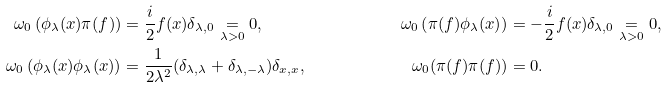Convert formula to latex. <formula><loc_0><loc_0><loc_500><loc_500>\omega _ { 0 } \left ( \phi _ { \lambda } ( x ) \pi ( f ) \right ) & = \frac { i } { 2 } f ( x ) \delta _ { \lambda , 0 } \underset { \lambda > 0 } { = } 0 , & \omega _ { 0 } \left ( \pi ( f ) \phi _ { \lambda } ( x ) \right ) & = - \frac { i } { 2 } f ( x ) \delta _ { \lambda , 0 } \underset { \lambda > 0 } { = } 0 , \\ \omega _ { 0 } \left ( \phi _ { \lambda } ( x ) \phi _ { \lambda } ( x ) \right ) & = \frac { 1 } { 2 \lambda ^ { 2 } } ( \delta _ { \lambda , \lambda } + \delta _ { \lambda , - \lambda } ) \delta _ { x , x } , & \omega _ { 0 } ( \pi ( f ) \pi ( f ) ) & = 0 .</formula> 